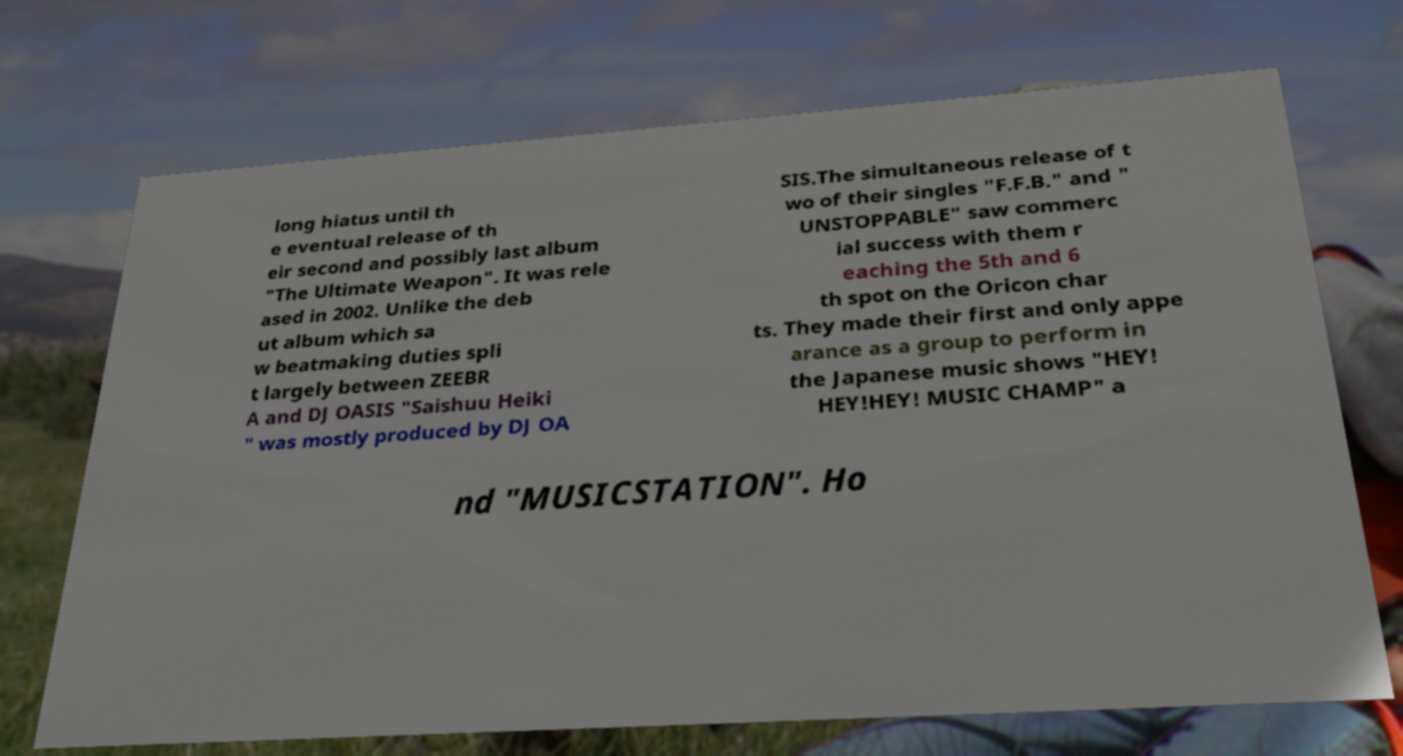Please read and relay the text visible in this image. What does it say? long hiatus until th e eventual release of th eir second and possibly last album "The Ultimate Weapon". It was rele ased in 2002. Unlike the deb ut album which sa w beatmaking duties spli t largely between ZEEBR A and DJ OASIS "Saishuu Heiki " was mostly produced by DJ OA SIS.The simultaneous release of t wo of their singles "F.F.B." and " UNSTOPPABLE" saw commerc ial success with them r eaching the 5th and 6 th spot on the Oricon char ts. They made their first and only appe arance as a group to perform in the Japanese music shows "HEY! HEY!HEY! MUSIC CHAMP" a nd "MUSICSTATION". Ho 